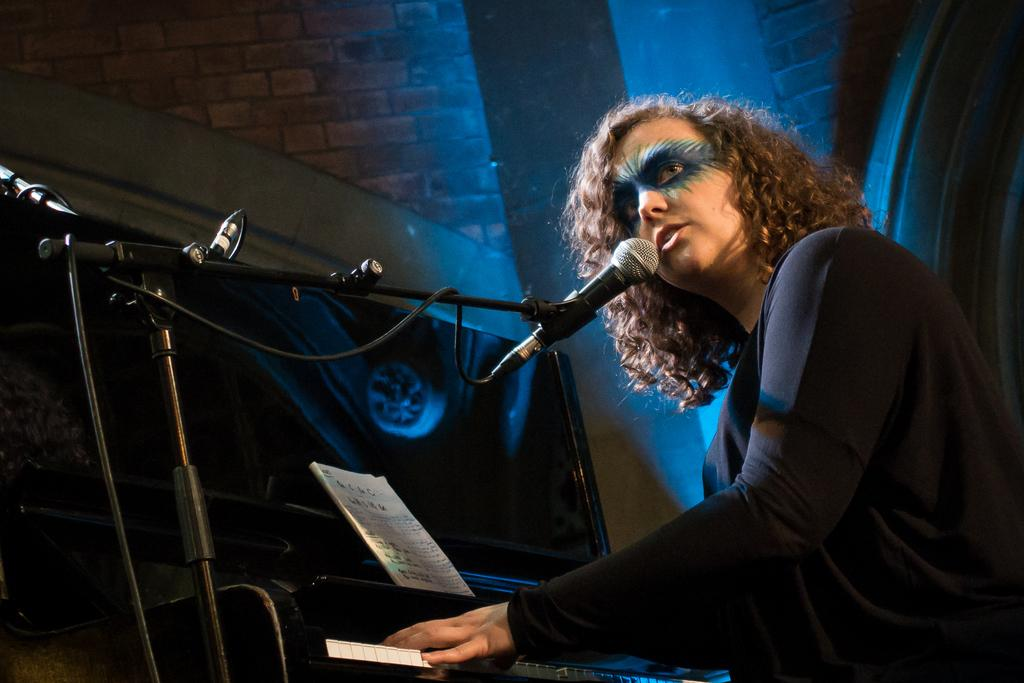Who is the main subject in the image? There is a woman in the image. What is the woman doing in the image? The woman is sitting in front of a piano and singing. What is the woman holding in front of her? The woman is holding a microphone in front of her. Can you describe the woman's hair in the image? The woman has brown, short hair. What is the woman's facial expression or direction of gaze in the image? The woman is looking to the side. What type of orange is the woman holding in the image? There is no orange present in the image; the woman is holding a microphone. What is the cause of the woman's singing in the image? The image does not provide information about the cause of the woman's singing. 